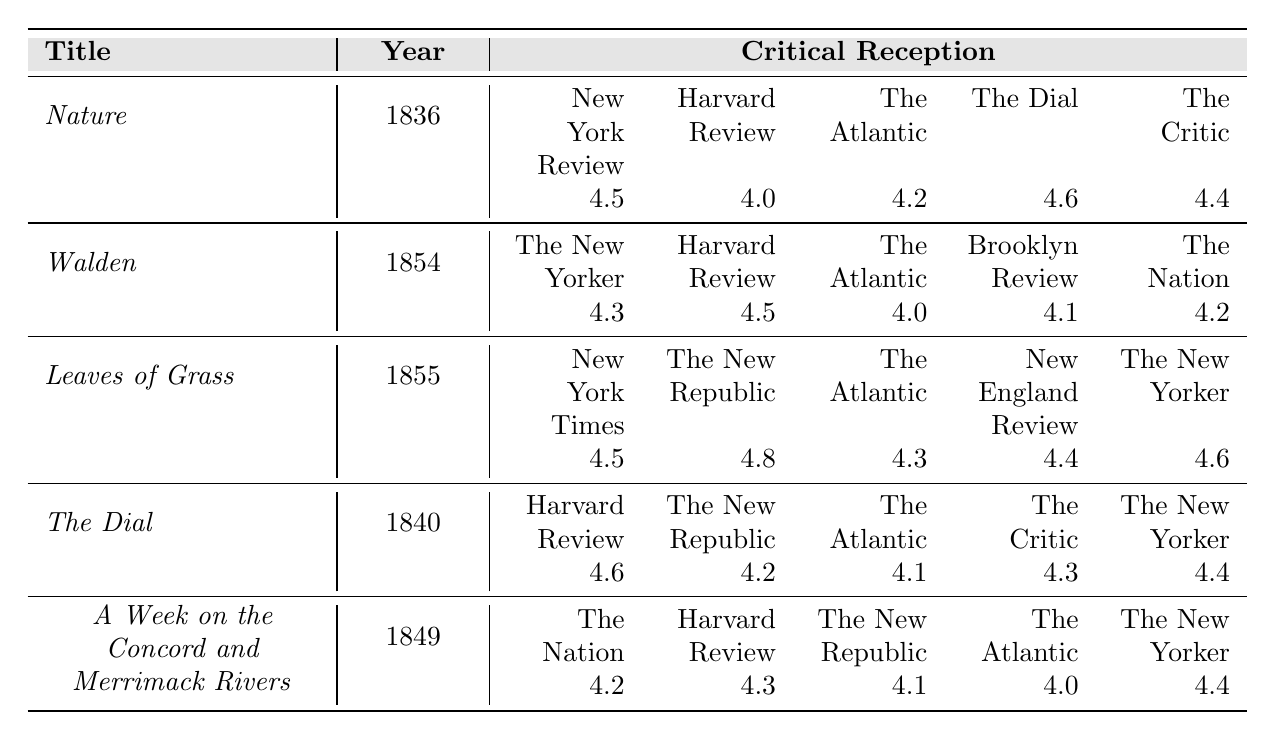What is the highest critical reception score for "Nature"? The highest score for "Nature" is found in "The Dial" with a rating of 4.6.
Answer: 4.6 Which author received the highest critical reception score across all reviews? The author with the highest score is Walt Whitman for "Leaves of Grass," with a score of 4.8 from "The New Republic."
Answer: 4.8 How many reviews did "Walden" receive and what is its average score? "Walden" received 5 reviews with scores of 4.3, 4.5, 4.0, 4.1, and 4.2. To find the average, sum these scores (4.3 + 4.5 + 4.0 + 4.1 + 4.2 = 21.1) and divide by 5, the average is 21.1/5 = 4.22.
Answer: 4.22 Was "The Atlantic" review ever rated higher than 4.5 for any of the listed books? A search of the "The Atlantic" ratings shows the highest was 4.3 for "Leaves of Grass," indicating that no book received over 4.5 from this review.
Answer: No List the critical reception scores for "A Week on the Concord and Merrimack Rivers." The scores listed are: The Nation (4.2), Harvard Review (4.3), The New Republic (4.1), The Atlantic (4.0), The New Yorker (4.4).
Answer: 4.2, 4.3, 4.1, 4.0, 4.4 Which book has the lowest score from "The New Yorker"? "A Week on the Concord and Merrimack Rivers" has a score of 4.4 from "The New Yorker," which is lower than "Walden" (4.3) and "Leaves of Grass" (4.6) from the same review.
Answer: A Week on the Concord and Merrimack Rivers What is the difference in scores between "The Dial" and "Walden"? Comparing the scores, "The Dial" received scores of 4.6, 4.2, 4.1, 4.3, and 4.4 while "Walden" received scores of 4.3, 4.5, 4.0, 4.1, and 4.2. To find the mean: The Dial average is (4.6 + 4.2 + 4.1 + 4.3 + 4.4)/5 = 4.44 and Walden's average is (4.3 + 4.5 + 4.0 + 4.1 + 4.2)/5 = 4.22. The difference is 4.44 - 4.22 = 0.22.
Answer: 0.22 Which two reviews rated "Leaves of Grass" the highest and what are their scores? "Leaves of Grass" received its highest reviews from "The New Republic," which rated it 4.8, and "The New Yorker," which rated it 4.6.
Answer: The New Republic (4.8), The New Yorker (4.6) Was there any review that rated "The Dial" above 4.5? Checking the ratings for "The Dial," "Harvard Review" rated it 4.6, which is above 4.5, confirming that it was rated higher.
Answer: Yes 